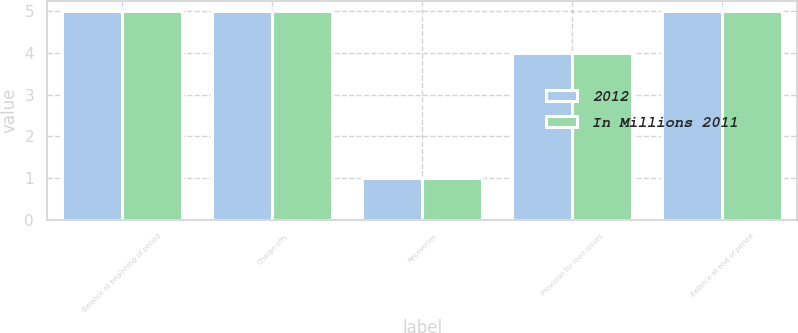Convert chart to OTSL. <chart><loc_0><loc_0><loc_500><loc_500><stacked_bar_chart><ecel><fcel>Balance at beginning of period<fcel>Charge-offs<fcel>Recoveries<fcel>Provision for loan losses<fcel>Balance at end of period<nl><fcel>2012<fcel>5<fcel>5<fcel>1<fcel>4<fcel>5<nl><fcel>In Millions 2011<fcel>5<fcel>5<fcel>1<fcel>4<fcel>5<nl></chart> 